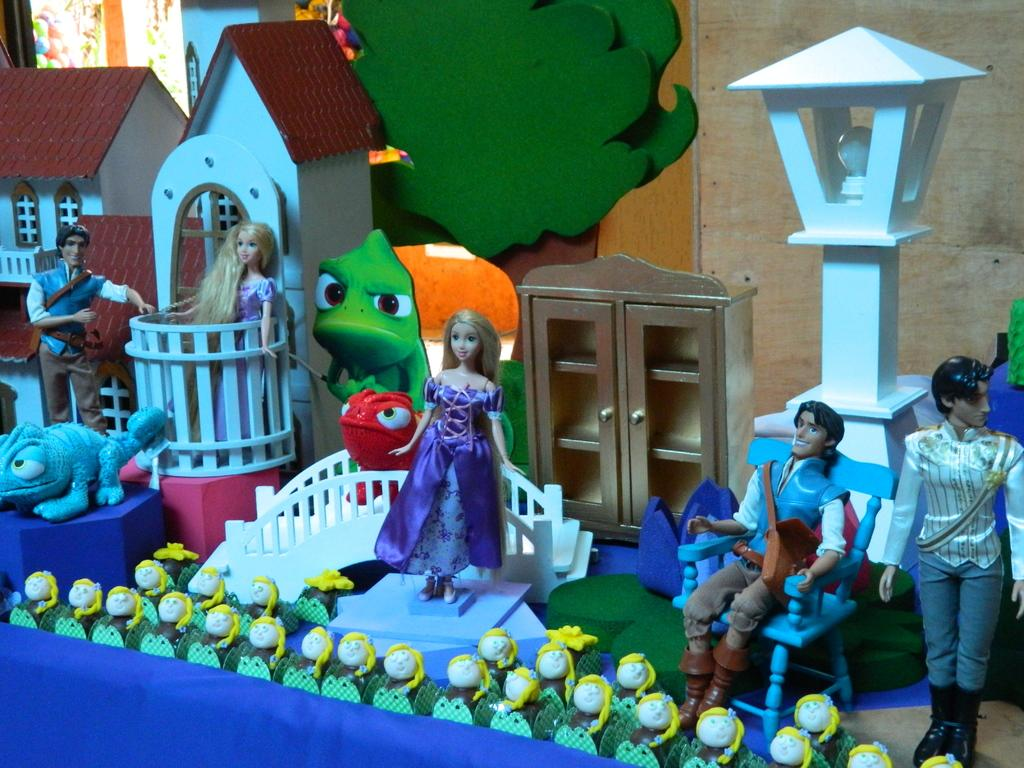What is the main subject of the image? The main subject of the image is a model of a Barbie house. How many pizzas are being tested in the image? There are no pizzas or testing activities present in the image; it features a model of a Barbie house. What type of art can be seen on the walls of the Barbie house in the image? The image does not provide enough detail to determine if there is any art on the walls of the Barbie house. 